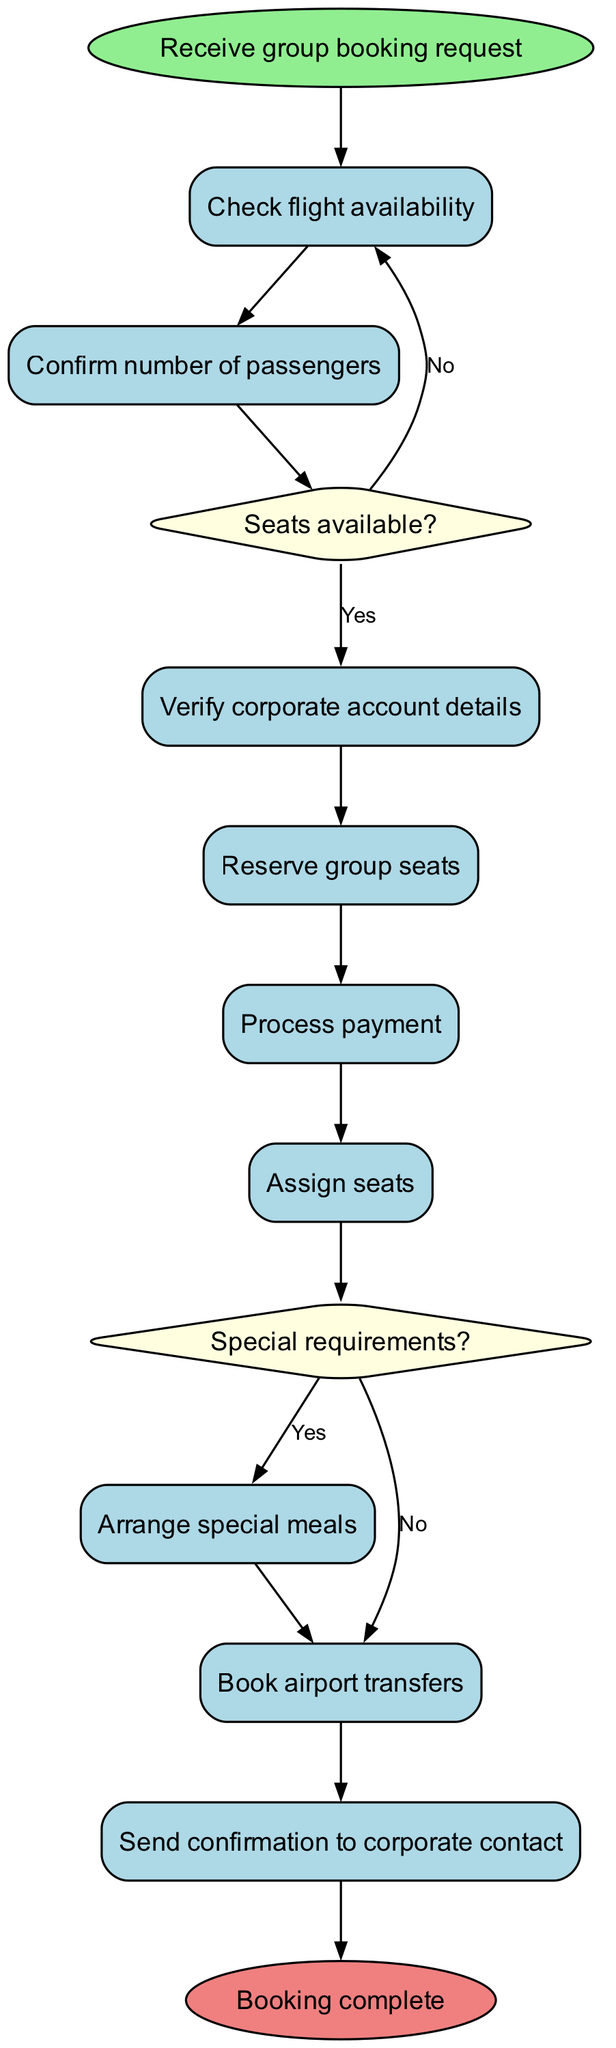What is the first activity in the diagram? The first activity after receiving the group booking request is to check flight availability. This can be determined by looking at the flow directly after the start node.
Answer: Check flight availability How many activities are listed in the diagram? By counting the activities mentioned, we find there are a total of 8 activities from "Check flight availability" to "Send confirmation to corporate contact."
Answer: 8 What decision is made after confirming the number of passengers? After confirming the number of passengers, the decision is made to check if there are seats available, which is represented by the question about seats availability.
Answer: Seats available? What happens if there are no seats available? If there are no seats available, the next action is to suggest alternative flights according to the decision made in the diagram. This is indicated as the flow stemming from the "no" option of the seats available decision.
Answer: Suggest alternative flights What happens after processing payment? After processing payment, the next step is to assign seats, which follows logically from the interaction flow in the diagram.
Answer: Assign seats Is there any activity related to special meal arrangements? Yes, there is an activity related to special meal arrangements, which occurs after assigning seats if there are any special requirements as confirmed in the decision.
Answer: Arrange special meals What occurs right before sending the confirmation to the corporate contact? The last activity that occurs before sending confirmation is booking airport transfers, indicating all prior steps need to be completed.
Answer: Book airport transfers How many decision points are there in the diagram? There are 2 decision points in the diagram: one about seat availability and another regarding special requirements.
Answer: 2 What is the final node of the diagram? The final node of the diagram, indicating the end of the process, is labeled as "Booking complete." This is the concluding step after all activities have been successfully concluded.
Answer: Booking complete 